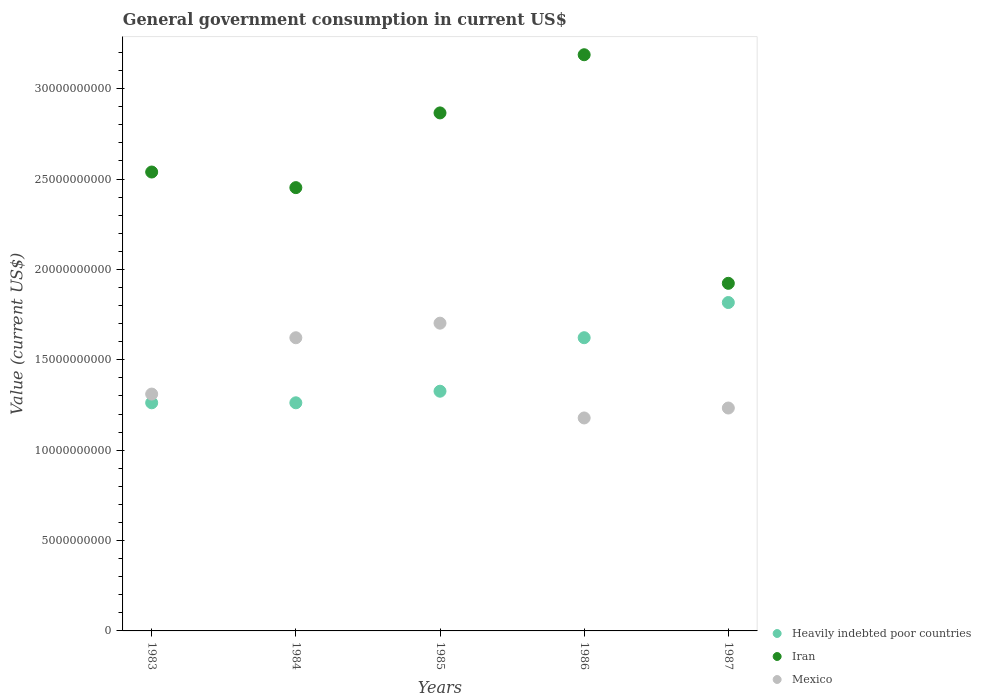How many different coloured dotlines are there?
Offer a terse response. 3. Is the number of dotlines equal to the number of legend labels?
Provide a short and direct response. Yes. What is the government conusmption in Heavily indebted poor countries in 1987?
Provide a short and direct response. 1.82e+1. Across all years, what is the maximum government conusmption in Heavily indebted poor countries?
Your answer should be compact. 1.82e+1. Across all years, what is the minimum government conusmption in Iran?
Your answer should be very brief. 1.92e+1. What is the total government conusmption in Iran in the graph?
Provide a succinct answer. 1.30e+11. What is the difference between the government conusmption in Mexico in 1984 and that in 1987?
Make the answer very short. 3.89e+09. What is the difference between the government conusmption in Iran in 1983 and the government conusmption in Heavily indebted poor countries in 1986?
Provide a short and direct response. 9.17e+09. What is the average government conusmption in Mexico per year?
Your response must be concise. 1.41e+1. In the year 1985, what is the difference between the government conusmption in Mexico and government conusmption in Heavily indebted poor countries?
Your answer should be very brief. 3.76e+09. What is the ratio of the government conusmption in Mexico in 1983 to that in 1987?
Ensure brevity in your answer.  1.06. Is the government conusmption in Heavily indebted poor countries in 1984 less than that in 1987?
Your response must be concise. Yes. Is the difference between the government conusmption in Mexico in 1983 and 1987 greater than the difference between the government conusmption in Heavily indebted poor countries in 1983 and 1987?
Give a very brief answer. Yes. What is the difference between the highest and the second highest government conusmption in Heavily indebted poor countries?
Give a very brief answer. 1.95e+09. What is the difference between the highest and the lowest government conusmption in Mexico?
Offer a terse response. 5.24e+09. In how many years, is the government conusmption in Iran greater than the average government conusmption in Iran taken over all years?
Provide a succinct answer. 2. Does the government conusmption in Mexico monotonically increase over the years?
Ensure brevity in your answer.  No. Is the government conusmption in Iran strictly greater than the government conusmption in Heavily indebted poor countries over the years?
Offer a terse response. Yes. How many dotlines are there?
Keep it short and to the point. 3. How many years are there in the graph?
Keep it short and to the point. 5. Are the values on the major ticks of Y-axis written in scientific E-notation?
Give a very brief answer. No. Does the graph contain any zero values?
Make the answer very short. No. Where does the legend appear in the graph?
Provide a short and direct response. Bottom right. How many legend labels are there?
Provide a succinct answer. 3. How are the legend labels stacked?
Ensure brevity in your answer.  Vertical. What is the title of the graph?
Provide a short and direct response. General government consumption in current US$. What is the label or title of the X-axis?
Provide a succinct answer. Years. What is the label or title of the Y-axis?
Provide a succinct answer. Value (current US$). What is the Value (current US$) of Heavily indebted poor countries in 1983?
Your answer should be very brief. 1.26e+1. What is the Value (current US$) of Iran in 1983?
Offer a terse response. 2.54e+1. What is the Value (current US$) in Mexico in 1983?
Offer a very short reply. 1.31e+1. What is the Value (current US$) of Heavily indebted poor countries in 1984?
Your response must be concise. 1.26e+1. What is the Value (current US$) in Iran in 1984?
Ensure brevity in your answer.  2.45e+1. What is the Value (current US$) in Mexico in 1984?
Give a very brief answer. 1.62e+1. What is the Value (current US$) of Heavily indebted poor countries in 1985?
Keep it short and to the point. 1.33e+1. What is the Value (current US$) in Iran in 1985?
Give a very brief answer. 2.87e+1. What is the Value (current US$) of Mexico in 1985?
Offer a terse response. 1.70e+1. What is the Value (current US$) of Heavily indebted poor countries in 1986?
Give a very brief answer. 1.62e+1. What is the Value (current US$) in Iran in 1986?
Offer a very short reply. 3.19e+1. What is the Value (current US$) of Mexico in 1986?
Offer a very short reply. 1.18e+1. What is the Value (current US$) of Heavily indebted poor countries in 1987?
Provide a short and direct response. 1.82e+1. What is the Value (current US$) in Iran in 1987?
Your answer should be compact. 1.92e+1. What is the Value (current US$) in Mexico in 1987?
Make the answer very short. 1.23e+1. Across all years, what is the maximum Value (current US$) of Heavily indebted poor countries?
Provide a succinct answer. 1.82e+1. Across all years, what is the maximum Value (current US$) in Iran?
Provide a succinct answer. 3.19e+1. Across all years, what is the maximum Value (current US$) of Mexico?
Give a very brief answer. 1.70e+1. Across all years, what is the minimum Value (current US$) of Heavily indebted poor countries?
Your answer should be very brief. 1.26e+1. Across all years, what is the minimum Value (current US$) of Iran?
Offer a terse response. 1.92e+1. Across all years, what is the minimum Value (current US$) of Mexico?
Make the answer very short. 1.18e+1. What is the total Value (current US$) in Heavily indebted poor countries in the graph?
Ensure brevity in your answer.  7.29e+1. What is the total Value (current US$) of Iran in the graph?
Make the answer very short. 1.30e+11. What is the total Value (current US$) of Mexico in the graph?
Keep it short and to the point. 7.05e+1. What is the difference between the Value (current US$) of Heavily indebted poor countries in 1983 and that in 1984?
Your answer should be very brief. -1.70e+05. What is the difference between the Value (current US$) in Iran in 1983 and that in 1984?
Your response must be concise. 8.63e+08. What is the difference between the Value (current US$) of Mexico in 1983 and that in 1984?
Offer a terse response. -3.12e+09. What is the difference between the Value (current US$) of Heavily indebted poor countries in 1983 and that in 1985?
Offer a terse response. -6.41e+08. What is the difference between the Value (current US$) in Iran in 1983 and that in 1985?
Make the answer very short. -3.27e+09. What is the difference between the Value (current US$) of Mexico in 1983 and that in 1985?
Your answer should be compact. -3.92e+09. What is the difference between the Value (current US$) of Heavily indebted poor countries in 1983 and that in 1986?
Offer a terse response. -3.60e+09. What is the difference between the Value (current US$) in Iran in 1983 and that in 1986?
Your answer should be very brief. -6.49e+09. What is the difference between the Value (current US$) of Mexico in 1983 and that in 1986?
Offer a very short reply. 1.32e+09. What is the difference between the Value (current US$) in Heavily indebted poor countries in 1983 and that in 1987?
Your response must be concise. -5.55e+09. What is the difference between the Value (current US$) of Iran in 1983 and that in 1987?
Keep it short and to the point. 6.16e+09. What is the difference between the Value (current US$) of Mexico in 1983 and that in 1987?
Ensure brevity in your answer.  7.72e+08. What is the difference between the Value (current US$) in Heavily indebted poor countries in 1984 and that in 1985?
Give a very brief answer. -6.41e+08. What is the difference between the Value (current US$) in Iran in 1984 and that in 1985?
Your answer should be compact. -4.13e+09. What is the difference between the Value (current US$) of Mexico in 1984 and that in 1985?
Your response must be concise. -8.06e+08. What is the difference between the Value (current US$) of Heavily indebted poor countries in 1984 and that in 1986?
Offer a terse response. -3.60e+09. What is the difference between the Value (current US$) in Iran in 1984 and that in 1986?
Make the answer very short. -7.35e+09. What is the difference between the Value (current US$) in Mexico in 1984 and that in 1986?
Offer a very short reply. 4.44e+09. What is the difference between the Value (current US$) in Heavily indebted poor countries in 1984 and that in 1987?
Provide a short and direct response. -5.55e+09. What is the difference between the Value (current US$) in Iran in 1984 and that in 1987?
Ensure brevity in your answer.  5.29e+09. What is the difference between the Value (current US$) of Mexico in 1984 and that in 1987?
Make the answer very short. 3.89e+09. What is the difference between the Value (current US$) of Heavily indebted poor countries in 1985 and that in 1986?
Provide a short and direct response. -2.96e+09. What is the difference between the Value (current US$) of Iran in 1985 and that in 1986?
Offer a very short reply. -3.22e+09. What is the difference between the Value (current US$) in Mexico in 1985 and that in 1986?
Provide a succinct answer. 5.24e+09. What is the difference between the Value (current US$) in Heavily indebted poor countries in 1985 and that in 1987?
Provide a short and direct response. -4.91e+09. What is the difference between the Value (current US$) in Iran in 1985 and that in 1987?
Your answer should be very brief. 9.43e+09. What is the difference between the Value (current US$) in Mexico in 1985 and that in 1987?
Keep it short and to the point. 4.69e+09. What is the difference between the Value (current US$) in Heavily indebted poor countries in 1986 and that in 1987?
Make the answer very short. -1.95e+09. What is the difference between the Value (current US$) of Iran in 1986 and that in 1987?
Ensure brevity in your answer.  1.26e+1. What is the difference between the Value (current US$) in Mexico in 1986 and that in 1987?
Give a very brief answer. -5.50e+08. What is the difference between the Value (current US$) of Heavily indebted poor countries in 1983 and the Value (current US$) of Iran in 1984?
Your answer should be compact. -1.19e+1. What is the difference between the Value (current US$) in Heavily indebted poor countries in 1983 and the Value (current US$) in Mexico in 1984?
Your answer should be compact. -3.60e+09. What is the difference between the Value (current US$) in Iran in 1983 and the Value (current US$) in Mexico in 1984?
Provide a succinct answer. 9.17e+09. What is the difference between the Value (current US$) in Heavily indebted poor countries in 1983 and the Value (current US$) in Iran in 1985?
Offer a terse response. -1.60e+1. What is the difference between the Value (current US$) in Heavily indebted poor countries in 1983 and the Value (current US$) in Mexico in 1985?
Offer a very short reply. -4.41e+09. What is the difference between the Value (current US$) of Iran in 1983 and the Value (current US$) of Mexico in 1985?
Offer a very short reply. 8.36e+09. What is the difference between the Value (current US$) in Heavily indebted poor countries in 1983 and the Value (current US$) in Iran in 1986?
Provide a succinct answer. -1.93e+1. What is the difference between the Value (current US$) of Heavily indebted poor countries in 1983 and the Value (current US$) of Mexico in 1986?
Ensure brevity in your answer.  8.39e+08. What is the difference between the Value (current US$) of Iran in 1983 and the Value (current US$) of Mexico in 1986?
Offer a terse response. 1.36e+1. What is the difference between the Value (current US$) of Heavily indebted poor countries in 1983 and the Value (current US$) of Iran in 1987?
Make the answer very short. -6.61e+09. What is the difference between the Value (current US$) of Heavily indebted poor countries in 1983 and the Value (current US$) of Mexico in 1987?
Make the answer very short. 2.89e+08. What is the difference between the Value (current US$) in Iran in 1983 and the Value (current US$) in Mexico in 1987?
Your answer should be compact. 1.31e+1. What is the difference between the Value (current US$) in Heavily indebted poor countries in 1984 and the Value (current US$) in Iran in 1985?
Give a very brief answer. -1.60e+1. What is the difference between the Value (current US$) of Heavily indebted poor countries in 1984 and the Value (current US$) of Mexico in 1985?
Offer a very short reply. -4.41e+09. What is the difference between the Value (current US$) of Iran in 1984 and the Value (current US$) of Mexico in 1985?
Provide a short and direct response. 7.50e+09. What is the difference between the Value (current US$) of Heavily indebted poor countries in 1984 and the Value (current US$) of Iran in 1986?
Your answer should be compact. -1.93e+1. What is the difference between the Value (current US$) in Heavily indebted poor countries in 1984 and the Value (current US$) in Mexico in 1986?
Your answer should be compact. 8.39e+08. What is the difference between the Value (current US$) in Iran in 1984 and the Value (current US$) in Mexico in 1986?
Give a very brief answer. 1.27e+1. What is the difference between the Value (current US$) in Heavily indebted poor countries in 1984 and the Value (current US$) in Iran in 1987?
Your answer should be very brief. -6.61e+09. What is the difference between the Value (current US$) in Heavily indebted poor countries in 1984 and the Value (current US$) in Mexico in 1987?
Provide a succinct answer. 2.89e+08. What is the difference between the Value (current US$) in Iran in 1984 and the Value (current US$) in Mexico in 1987?
Give a very brief answer. 1.22e+1. What is the difference between the Value (current US$) in Heavily indebted poor countries in 1985 and the Value (current US$) in Iran in 1986?
Your answer should be very brief. -1.86e+1. What is the difference between the Value (current US$) in Heavily indebted poor countries in 1985 and the Value (current US$) in Mexico in 1986?
Offer a very short reply. 1.48e+09. What is the difference between the Value (current US$) in Iran in 1985 and the Value (current US$) in Mexico in 1986?
Offer a terse response. 1.69e+1. What is the difference between the Value (current US$) of Heavily indebted poor countries in 1985 and the Value (current US$) of Iran in 1987?
Offer a very short reply. -5.97e+09. What is the difference between the Value (current US$) in Heavily indebted poor countries in 1985 and the Value (current US$) in Mexico in 1987?
Ensure brevity in your answer.  9.30e+08. What is the difference between the Value (current US$) of Iran in 1985 and the Value (current US$) of Mexico in 1987?
Offer a terse response. 1.63e+1. What is the difference between the Value (current US$) in Heavily indebted poor countries in 1986 and the Value (current US$) in Iran in 1987?
Provide a succinct answer. -3.01e+09. What is the difference between the Value (current US$) of Heavily indebted poor countries in 1986 and the Value (current US$) of Mexico in 1987?
Your answer should be very brief. 3.89e+09. What is the difference between the Value (current US$) of Iran in 1986 and the Value (current US$) of Mexico in 1987?
Ensure brevity in your answer.  1.95e+1. What is the average Value (current US$) in Heavily indebted poor countries per year?
Offer a terse response. 1.46e+1. What is the average Value (current US$) in Iran per year?
Your response must be concise. 2.59e+1. What is the average Value (current US$) in Mexico per year?
Make the answer very short. 1.41e+1. In the year 1983, what is the difference between the Value (current US$) of Heavily indebted poor countries and Value (current US$) of Iran?
Make the answer very short. -1.28e+1. In the year 1983, what is the difference between the Value (current US$) in Heavily indebted poor countries and Value (current US$) in Mexico?
Your answer should be very brief. -4.83e+08. In the year 1983, what is the difference between the Value (current US$) of Iran and Value (current US$) of Mexico?
Offer a terse response. 1.23e+1. In the year 1984, what is the difference between the Value (current US$) of Heavily indebted poor countries and Value (current US$) of Iran?
Keep it short and to the point. -1.19e+1. In the year 1984, what is the difference between the Value (current US$) of Heavily indebted poor countries and Value (current US$) of Mexico?
Make the answer very short. -3.60e+09. In the year 1984, what is the difference between the Value (current US$) of Iran and Value (current US$) of Mexico?
Keep it short and to the point. 8.30e+09. In the year 1985, what is the difference between the Value (current US$) in Heavily indebted poor countries and Value (current US$) in Iran?
Your response must be concise. -1.54e+1. In the year 1985, what is the difference between the Value (current US$) in Heavily indebted poor countries and Value (current US$) in Mexico?
Provide a short and direct response. -3.76e+09. In the year 1985, what is the difference between the Value (current US$) of Iran and Value (current US$) of Mexico?
Make the answer very short. 1.16e+1. In the year 1986, what is the difference between the Value (current US$) in Heavily indebted poor countries and Value (current US$) in Iran?
Make the answer very short. -1.57e+1. In the year 1986, what is the difference between the Value (current US$) of Heavily indebted poor countries and Value (current US$) of Mexico?
Ensure brevity in your answer.  4.44e+09. In the year 1986, what is the difference between the Value (current US$) of Iran and Value (current US$) of Mexico?
Provide a succinct answer. 2.01e+1. In the year 1987, what is the difference between the Value (current US$) of Heavily indebted poor countries and Value (current US$) of Iran?
Make the answer very short. -1.06e+09. In the year 1987, what is the difference between the Value (current US$) of Heavily indebted poor countries and Value (current US$) of Mexico?
Ensure brevity in your answer.  5.84e+09. In the year 1987, what is the difference between the Value (current US$) in Iran and Value (current US$) in Mexico?
Offer a very short reply. 6.90e+09. What is the ratio of the Value (current US$) of Heavily indebted poor countries in 1983 to that in 1984?
Ensure brevity in your answer.  1. What is the ratio of the Value (current US$) in Iran in 1983 to that in 1984?
Ensure brevity in your answer.  1.04. What is the ratio of the Value (current US$) in Mexico in 1983 to that in 1984?
Provide a short and direct response. 0.81. What is the ratio of the Value (current US$) in Heavily indebted poor countries in 1983 to that in 1985?
Ensure brevity in your answer.  0.95. What is the ratio of the Value (current US$) of Iran in 1983 to that in 1985?
Your answer should be compact. 0.89. What is the ratio of the Value (current US$) of Mexico in 1983 to that in 1985?
Your response must be concise. 0.77. What is the ratio of the Value (current US$) in Heavily indebted poor countries in 1983 to that in 1986?
Offer a terse response. 0.78. What is the ratio of the Value (current US$) of Iran in 1983 to that in 1986?
Ensure brevity in your answer.  0.8. What is the ratio of the Value (current US$) of Mexico in 1983 to that in 1986?
Keep it short and to the point. 1.11. What is the ratio of the Value (current US$) in Heavily indebted poor countries in 1983 to that in 1987?
Give a very brief answer. 0.69. What is the ratio of the Value (current US$) of Iran in 1983 to that in 1987?
Offer a terse response. 1.32. What is the ratio of the Value (current US$) of Mexico in 1983 to that in 1987?
Your response must be concise. 1.06. What is the ratio of the Value (current US$) of Heavily indebted poor countries in 1984 to that in 1985?
Give a very brief answer. 0.95. What is the ratio of the Value (current US$) of Iran in 1984 to that in 1985?
Provide a succinct answer. 0.86. What is the ratio of the Value (current US$) in Mexico in 1984 to that in 1985?
Keep it short and to the point. 0.95. What is the ratio of the Value (current US$) in Heavily indebted poor countries in 1984 to that in 1986?
Make the answer very short. 0.78. What is the ratio of the Value (current US$) in Iran in 1984 to that in 1986?
Offer a very short reply. 0.77. What is the ratio of the Value (current US$) in Mexico in 1984 to that in 1986?
Give a very brief answer. 1.38. What is the ratio of the Value (current US$) of Heavily indebted poor countries in 1984 to that in 1987?
Offer a very short reply. 0.69. What is the ratio of the Value (current US$) in Iran in 1984 to that in 1987?
Your answer should be very brief. 1.28. What is the ratio of the Value (current US$) of Mexico in 1984 to that in 1987?
Give a very brief answer. 1.32. What is the ratio of the Value (current US$) of Heavily indebted poor countries in 1985 to that in 1986?
Keep it short and to the point. 0.82. What is the ratio of the Value (current US$) in Iran in 1985 to that in 1986?
Make the answer very short. 0.9. What is the ratio of the Value (current US$) of Mexico in 1985 to that in 1986?
Make the answer very short. 1.45. What is the ratio of the Value (current US$) of Heavily indebted poor countries in 1985 to that in 1987?
Your response must be concise. 0.73. What is the ratio of the Value (current US$) in Iran in 1985 to that in 1987?
Your answer should be very brief. 1.49. What is the ratio of the Value (current US$) of Mexico in 1985 to that in 1987?
Your answer should be compact. 1.38. What is the ratio of the Value (current US$) of Heavily indebted poor countries in 1986 to that in 1987?
Provide a short and direct response. 0.89. What is the ratio of the Value (current US$) in Iran in 1986 to that in 1987?
Give a very brief answer. 1.66. What is the ratio of the Value (current US$) of Mexico in 1986 to that in 1987?
Provide a succinct answer. 0.96. What is the difference between the highest and the second highest Value (current US$) in Heavily indebted poor countries?
Make the answer very short. 1.95e+09. What is the difference between the highest and the second highest Value (current US$) in Iran?
Your response must be concise. 3.22e+09. What is the difference between the highest and the second highest Value (current US$) of Mexico?
Offer a very short reply. 8.06e+08. What is the difference between the highest and the lowest Value (current US$) of Heavily indebted poor countries?
Offer a very short reply. 5.55e+09. What is the difference between the highest and the lowest Value (current US$) in Iran?
Offer a terse response. 1.26e+1. What is the difference between the highest and the lowest Value (current US$) of Mexico?
Your answer should be compact. 5.24e+09. 